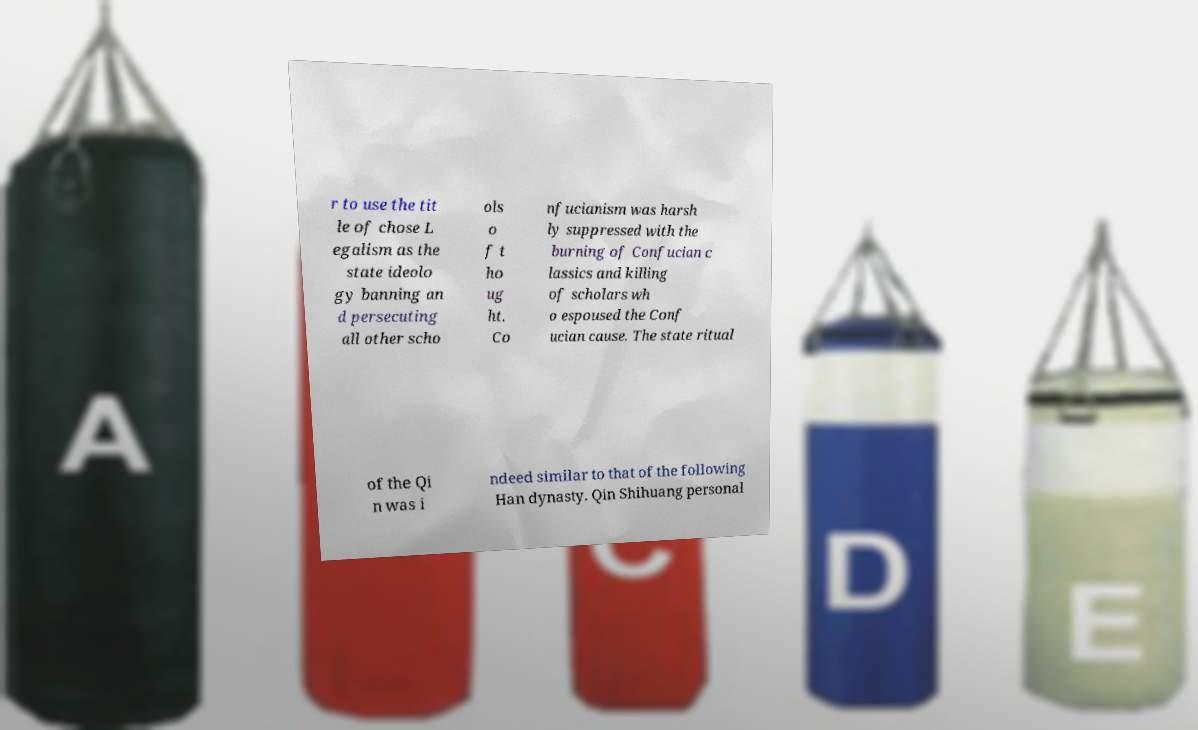Could you extract and type out the text from this image? r to use the tit le of chose L egalism as the state ideolo gy banning an d persecuting all other scho ols o f t ho ug ht. Co nfucianism was harsh ly suppressed with the burning of Confucian c lassics and killing of scholars wh o espoused the Conf ucian cause. The state ritual of the Qi n was i ndeed similar to that of the following Han dynasty. Qin Shihuang personal 